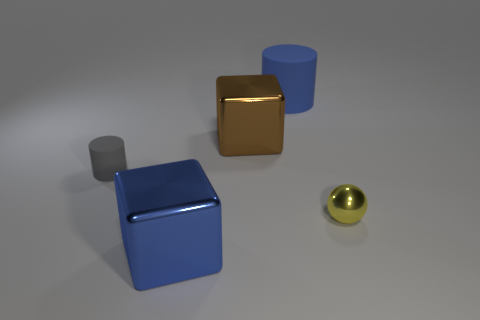What is the material of the big cube that is the same color as the big rubber thing?
Give a very brief answer. Metal. What number of tiny cyan shiny things are there?
Make the answer very short. 0. There is a cube that is in front of the matte thing to the left of the cylinder right of the blue metal thing; what is its color?
Offer a terse response. Blue. Does the tiny shiny object have the same color as the small cylinder?
Give a very brief answer. No. What number of blocks are behind the yellow metal sphere and in front of the tiny sphere?
Provide a short and direct response. 0. How many metallic things are big cubes or big cylinders?
Provide a short and direct response. 2. What is the material of the small thing that is on the left side of the cube in front of the small ball?
Make the answer very short. Rubber. The large object that is the same color as the large rubber cylinder is what shape?
Your answer should be compact. Cube. The gray thing that is the same size as the metal ball is what shape?
Your answer should be very brief. Cylinder. Are there fewer small brown rubber cylinders than large blue metal objects?
Offer a very short reply. Yes. 